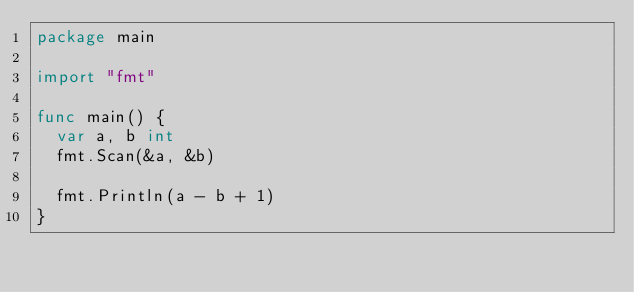<code> <loc_0><loc_0><loc_500><loc_500><_Go_>package main

import "fmt"

func main() {
	var a, b int
	fmt.Scan(&a, &b)

	fmt.Println(a - b + 1)
}
</code> 